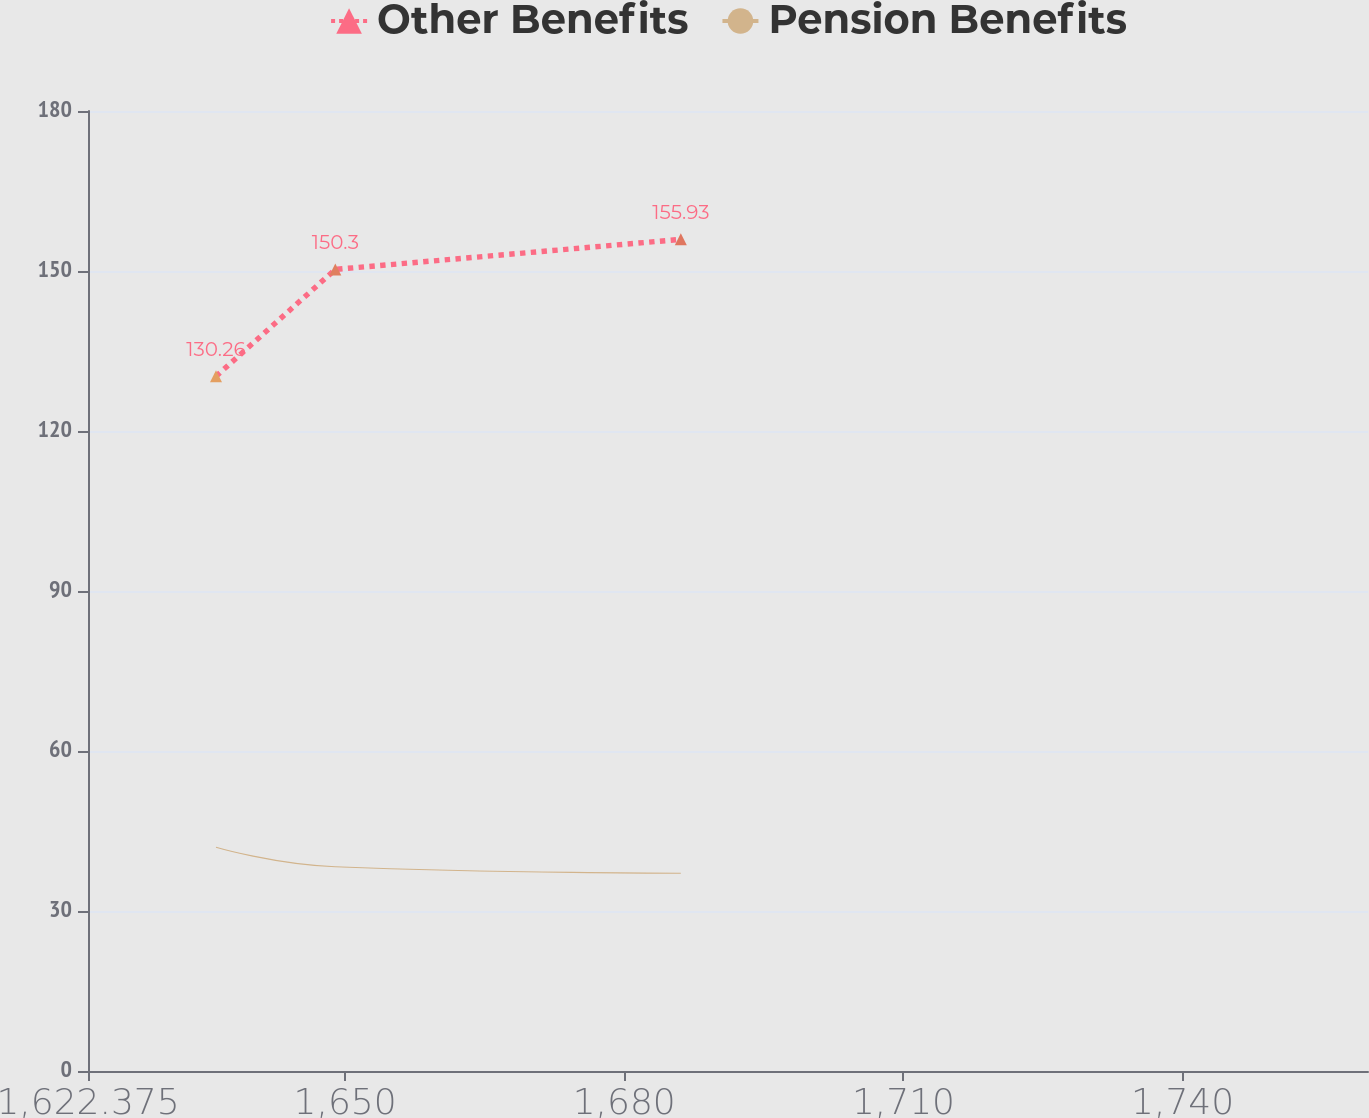<chart> <loc_0><loc_0><loc_500><loc_500><line_chart><ecel><fcel>Other Benefits<fcel>Pension Benefits<nl><fcel>1636.13<fcel>130.26<fcel>41.96<nl><fcel>1648.95<fcel>150.3<fcel>38.3<nl><fcel>1686.08<fcel>155.93<fcel>37.08<nl><fcel>1760.86<fcel>124.63<fcel>34.46<nl><fcel>1773.68<fcel>180.96<fcel>30.28<nl></chart> 